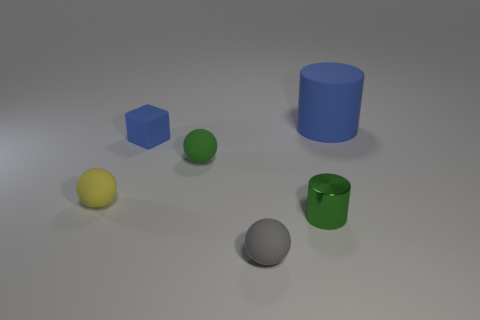What material is the yellow thing? rubber 